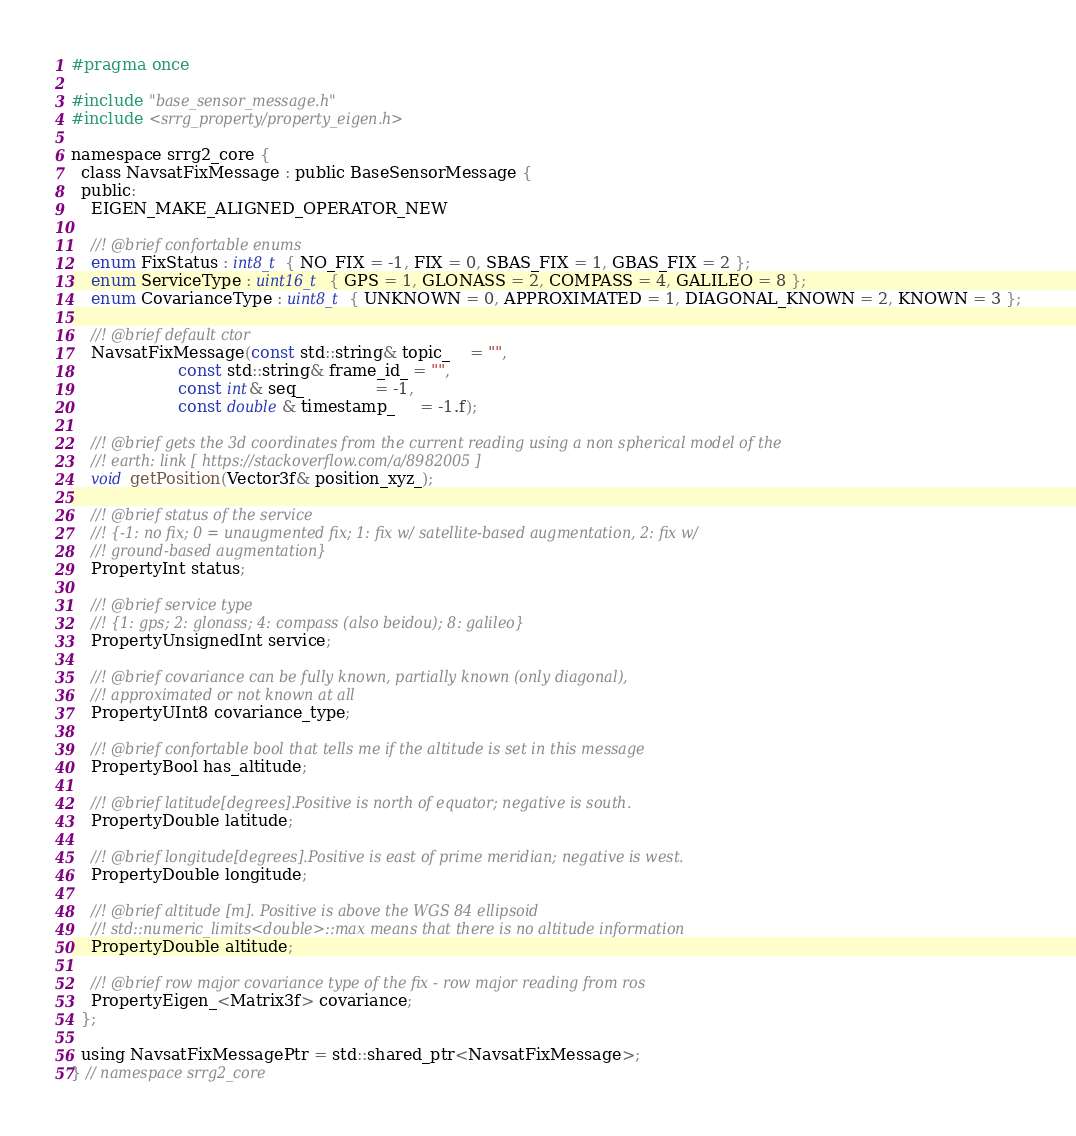Convert code to text. <code><loc_0><loc_0><loc_500><loc_500><_C_>#pragma once

#include "base_sensor_message.h"
#include <srrg_property/property_eigen.h>

namespace srrg2_core {
  class NavsatFixMessage : public BaseSensorMessage {
  public:
    EIGEN_MAKE_ALIGNED_OPERATOR_NEW

    //! @brief confortable enums
    enum FixStatus : int8_t { NO_FIX = -1, FIX = 0, SBAS_FIX = 1, GBAS_FIX = 2 };
    enum ServiceType : uint16_t { GPS = 1, GLONASS = 2, COMPASS = 4, GALILEO = 8 };
    enum CovarianceType : uint8_t { UNKNOWN = 0, APPROXIMATED = 1, DIAGONAL_KNOWN = 2, KNOWN = 3 };

    //! @brief default ctor
    NavsatFixMessage(const std::string& topic_    = "",
                     const std::string& frame_id_ = "",
                     const int& seq_              = -1,
                     const double& timestamp_     = -1.f);

    //! @brief gets the 3d coordinates from the current reading using a non spherical model of the
    //! earth: link [ https://stackoverflow.com/a/8982005 ]
    void getPosition(Vector3f& position_xyz_);

    //! @brief status of the service
    //! {-1: no fix; 0 = unaugmented fix; 1: fix w/ satellite-based augmentation, 2: fix w/
    //! ground-based augmentation}
    PropertyInt status;

    //! @brief service type
    //! {1: gps; 2: glonass; 4: compass (also beidou); 8: galileo}
    PropertyUnsignedInt service;

    //! @brief covariance can be fully known, partially known (only diagonal),
    //! approximated or not known at all
    PropertyUInt8 covariance_type;

    //! @brief confortable bool that tells me if the altitude is set in this message
    PropertyBool has_altitude;

    //! @brief latitude[degrees].Positive is north of equator; negative is south.
    PropertyDouble latitude;

    //! @brief longitude[degrees].Positive is east of prime meridian; negative is west.
    PropertyDouble longitude;

    //! @brief altitude [m]. Positive is above the WGS 84 ellipsoid
    //! std::numeric_limits<double>::max means that there is no altitude information
    PropertyDouble altitude;

    //! @brief row major covariance type of the fix - row major reading from ros
    PropertyEigen_<Matrix3f> covariance;
  };

  using NavsatFixMessagePtr = std::shared_ptr<NavsatFixMessage>;
} // namespace srrg2_core
</code> 